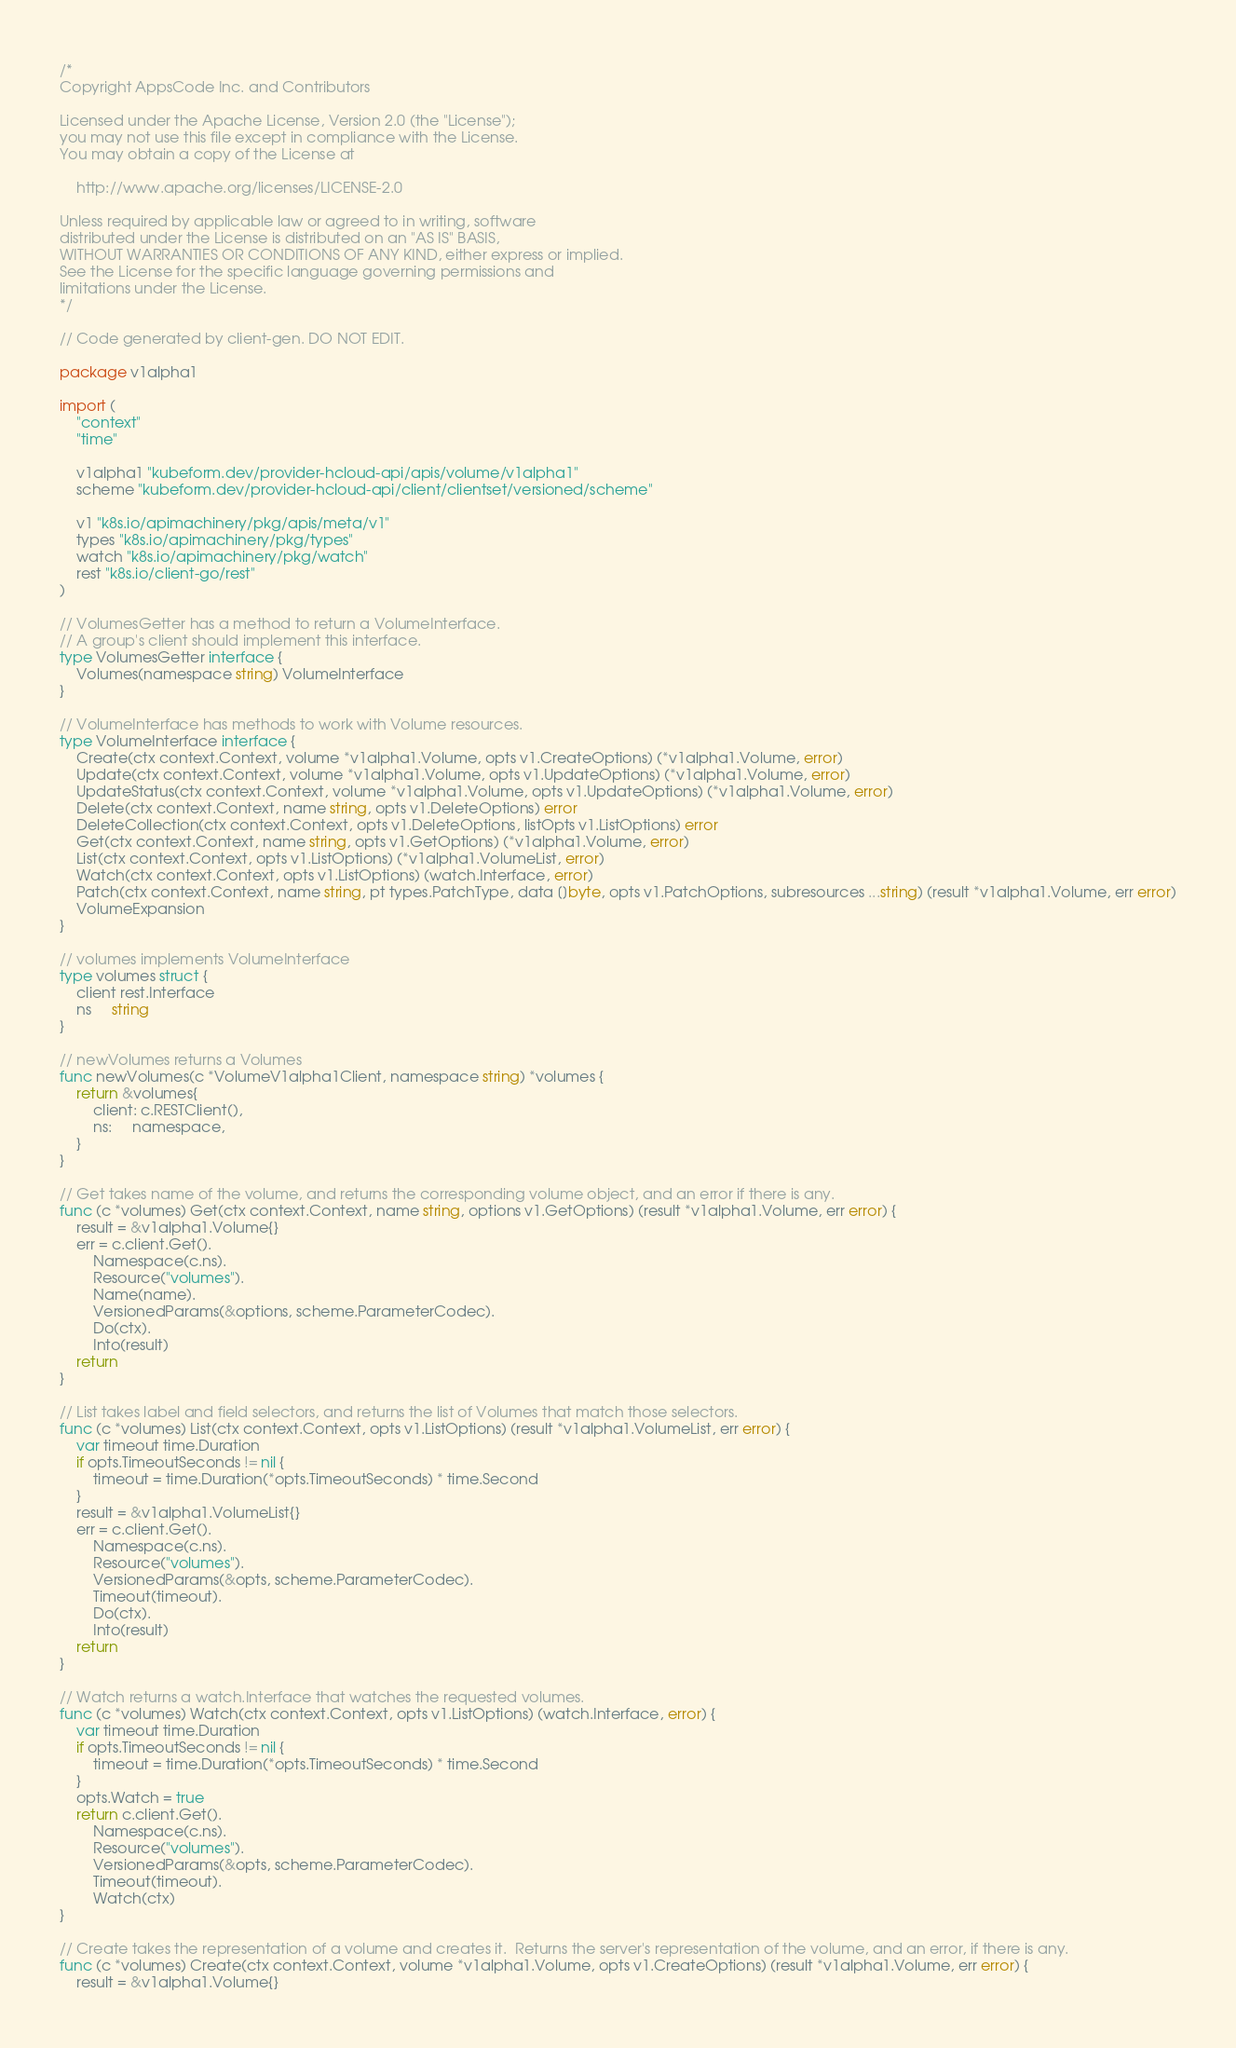<code> <loc_0><loc_0><loc_500><loc_500><_Go_>/*
Copyright AppsCode Inc. and Contributors

Licensed under the Apache License, Version 2.0 (the "License");
you may not use this file except in compliance with the License.
You may obtain a copy of the License at

    http://www.apache.org/licenses/LICENSE-2.0

Unless required by applicable law or agreed to in writing, software
distributed under the License is distributed on an "AS IS" BASIS,
WITHOUT WARRANTIES OR CONDITIONS OF ANY KIND, either express or implied.
See the License for the specific language governing permissions and
limitations under the License.
*/

// Code generated by client-gen. DO NOT EDIT.

package v1alpha1

import (
	"context"
	"time"

	v1alpha1 "kubeform.dev/provider-hcloud-api/apis/volume/v1alpha1"
	scheme "kubeform.dev/provider-hcloud-api/client/clientset/versioned/scheme"

	v1 "k8s.io/apimachinery/pkg/apis/meta/v1"
	types "k8s.io/apimachinery/pkg/types"
	watch "k8s.io/apimachinery/pkg/watch"
	rest "k8s.io/client-go/rest"
)

// VolumesGetter has a method to return a VolumeInterface.
// A group's client should implement this interface.
type VolumesGetter interface {
	Volumes(namespace string) VolumeInterface
}

// VolumeInterface has methods to work with Volume resources.
type VolumeInterface interface {
	Create(ctx context.Context, volume *v1alpha1.Volume, opts v1.CreateOptions) (*v1alpha1.Volume, error)
	Update(ctx context.Context, volume *v1alpha1.Volume, opts v1.UpdateOptions) (*v1alpha1.Volume, error)
	UpdateStatus(ctx context.Context, volume *v1alpha1.Volume, opts v1.UpdateOptions) (*v1alpha1.Volume, error)
	Delete(ctx context.Context, name string, opts v1.DeleteOptions) error
	DeleteCollection(ctx context.Context, opts v1.DeleteOptions, listOpts v1.ListOptions) error
	Get(ctx context.Context, name string, opts v1.GetOptions) (*v1alpha1.Volume, error)
	List(ctx context.Context, opts v1.ListOptions) (*v1alpha1.VolumeList, error)
	Watch(ctx context.Context, opts v1.ListOptions) (watch.Interface, error)
	Patch(ctx context.Context, name string, pt types.PatchType, data []byte, opts v1.PatchOptions, subresources ...string) (result *v1alpha1.Volume, err error)
	VolumeExpansion
}

// volumes implements VolumeInterface
type volumes struct {
	client rest.Interface
	ns     string
}

// newVolumes returns a Volumes
func newVolumes(c *VolumeV1alpha1Client, namespace string) *volumes {
	return &volumes{
		client: c.RESTClient(),
		ns:     namespace,
	}
}

// Get takes name of the volume, and returns the corresponding volume object, and an error if there is any.
func (c *volumes) Get(ctx context.Context, name string, options v1.GetOptions) (result *v1alpha1.Volume, err error) {
	result = &v1alpha1.Volume{}
	err = c.client.Get().
		Namespace(c.ns).
		Resource("volumes").
		Name(name).
		VersionedParams(&options, scheme.ParameterCodec).
		Do(ctx).
		Into(result)
	return
}

// List takes label and field selectors, and returns the list of Volumes that match those selectors.
func (c *volumes) List(ctx context.Context, opts v1.ListOptions) (result *v1alpha1.VolumeList, err error) {
	var timeout time.Duration
	if opts.TimeoutSeconds != nil {
		timeout = time.Duration(*opts.TimeoutSeconds) * time.Second
	}
	result = &v1alpha1.VolumeList{}
	err = c.client.Get().
		Namespace(c.ns).
		Resource("volumes").
		VersionedParams(&opts, scheme.ParameterCodec).
		Timeout(timeout).
		Do(ctx).
		Into(result)
	return
}

// Watch returns a watch.Interface that watches the requested volumes.
func (c *volumes) Watch(ctx context.Context, opts v1.ListOptions) (watch.Interface, error) {
	var timeout time.Duration
	if opts.TimeoutSeconds != nil {
		timeout = time.Duration(*opts.TimeoutSeconds) * time.Second
	}
	opts.Watch = true
	return c.client.Get().
		Namespace(c.ns).
		Resource("volumes").
		VersionedParams(&opts, scheme.ParameterCodec).
		Timeout(timeout).
		Watch(ctx)
}

// Create takes the representation of a volume and creates it.  Returns the server's representation of the volume, and an error, if there is any.
func (c *volumes) Create(ctx context.Context, volume *v1alpha1.Volume, opts v1.CreateOptions) (result *v1alpha1.Volume, err error) {
	result = &v1alpha1.Volume{}</code> 